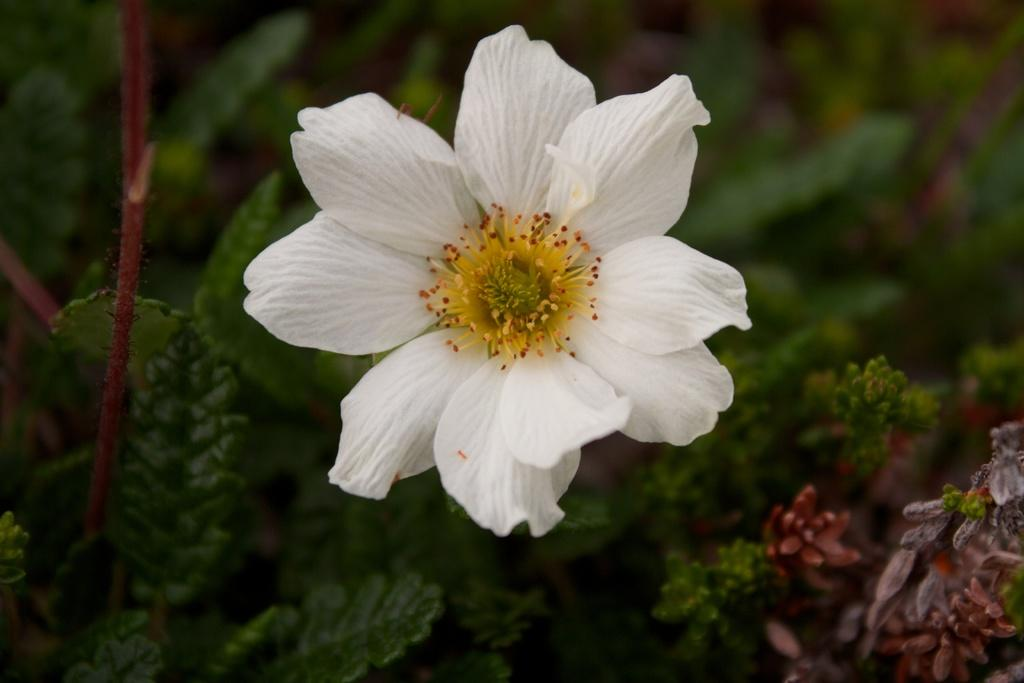What type of flower can be seen in the image? There is a white color flower in the image. What else is present in the image besides the flower? There are plants in the image. How does the wind affect the sail in the image? There is no sail present in the image, so the wind's effect cannot be determined. 